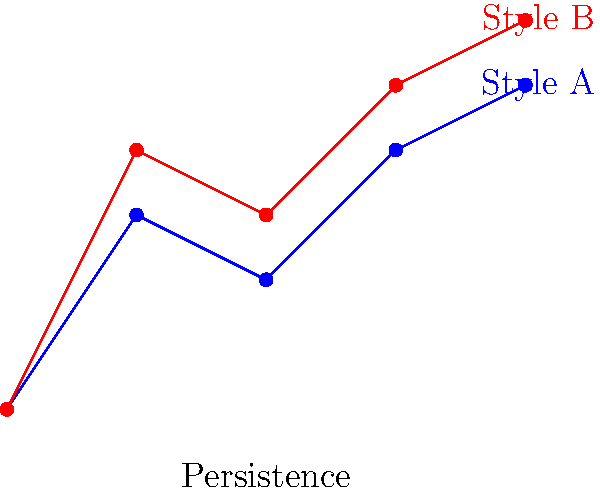In the application of persistent homology to compare handwriting styles across multiple historical documents, how would you interpret the differences between Style A and Style B in the persistence diagram shown above? To interpret the differences between Style A and Style B using persistent homology, we need to follow these steps:

1. Understand the persistence diagram:
   - The x-axis represents persistence (longevity of features)
   - The y-axis represents features (topological characteristics)

2. Analyze Style A (blue points):
   - Features appear at lower persistence values
   - More gradual increase in feature complexity

3. Analyze Style B (red points):
   - Features appear at higher persistence values
   - Steeper increase in feature complexity

4. Compare the two styles:
   - Style B has more persistent features overall
   - Style B shows higher topological complexity at each persistence level

5. Interpret the results:
   - Style B likely represents a more ornate or complex handwriting style
   - Style A appears to be simpler or more streamlined

6. Consider historical context:
   - Style B might be associated with formal or ceremonial documents
   - Style A could represent everyday or utilitarian writing

7. Implications for document analysis:
   - These differences can help categorize documents by style or purpose
   - May assist in identifying or authenticating historical manuscripts

The persistent homology analysis reveals that Style B has more complex and persistent topological features compared to Style A, suggesting a more elaborate handwriting style that could be indicative of formal or important historical documents.
Answer: Style B shows higher persistence and complexity, indicating a more elaborate handwriting style potentially associated with formal historical documents. 